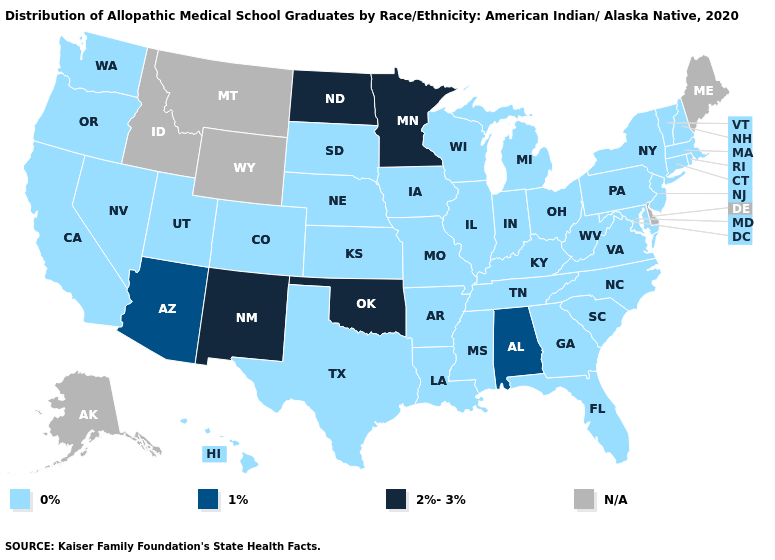Does New Mexico have the highest value in the West?
Short answer required. Yes. What is the highest value in the MidWest ?
Be succinct. 2%-3%. Does Oklahoma have the highest value in the South?
Give a very brief answer. Yes. What is the value of Rhode Island?
Short answer required. 0%. Which states have the lowest value in the USA?
Be succinct. Arkansas, California, Colorado, Connecticut, Florida, Georgia, Hawaii, Illinois, Indiana, Iowa, Kansas, Kentucky, Louisiana, Maryland, Massachusetts, Michigan, Mississippi, Missouri, Nebraska, Nevada, New Hampshire, New Jersey, New York, North Carolina, Ohio, Oregon, Pennsylvania, Rhode Island, South Carolina, South Dakota, Tennessee, Texas, Utah, Vermont, Virginia, Washington, West Virginia, Wisconsin. Name the states that have a value in the range 0%?
Short answer required. Arkansas, California, Colorado, Connecticut, Florida, Georgia, Hawaii, Illinois, Indiana, Iowa, Kansas, Kentucky, Louisiana, Maryland, Massachusetts, Michigan, Mississippi, Missouri, Nebraska, Nevada, New Hampshire, New Jersey, New York, North Carolina, Ohio, Oregon, Pennsylvania, Rhode Island, South Carolina, South Dakota, Tennessee, Texas, Utah, Vermont, Virginia, Washington, West Virginia, Wisconsin. What is the lowest value in the USA?
Quick response, please. 0%. What is the value of North Carolina?
Concise answer only. 0%. Name the states that have a value in the range 0%?
Concise answer only. Arkansas, California, Colorado, Connecticut, Florida, Georgia, Hawaii, Illinois, Indiana, Iowa, Kansas, Kentucky, Louisiana, Maryland, Massachusetts, Michigan, Mississippi, Missouri, Nebraska, Nevada, New Hampshire, New Jersey, New York, North Carolina, Ohio, Oregon, Pennsylvania, Rhode Island, South Carolina, South Dakota, Tennessee, Texas, Utah, Vermont, Virginia, Washington, West Virginia, Wisconsin. What is the value of Montana?
Answer briefly. N/A. Name the states that have a value in the range 2%-3%?
Concise answer only. Minnesota, New Mexico, North Dakota, Oklahoma. Name the states that have a value in the range N/A?
Keep it brief. Alaska, Delaware, Idaho, Maine, Montana, Wyoming. Name the states that have a value in the range 1%?
Write a very short answer. Alabama, Arizona. 